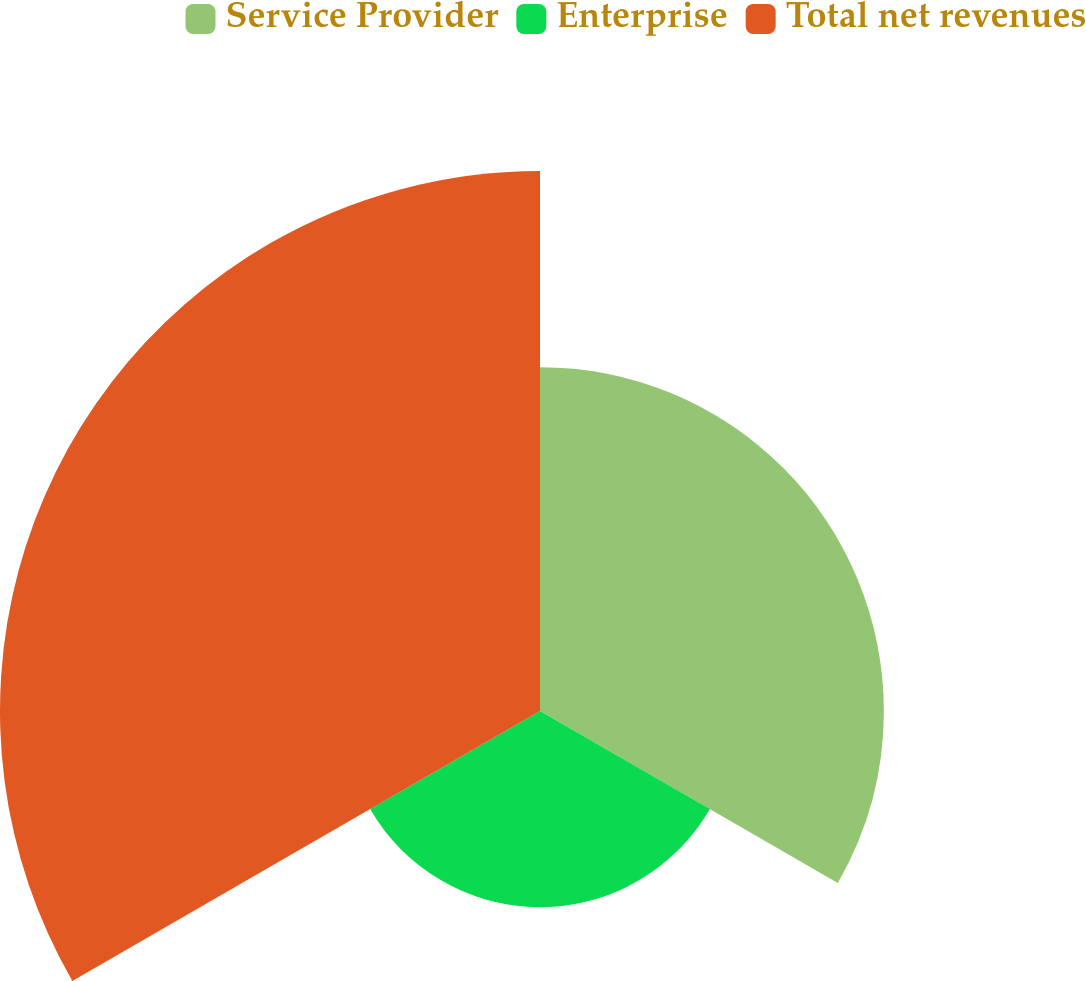Convert chart. <chart><loc_0><loc_0><loc_500><loc_500><pie_chart><fcel>Service Provider<fcel>Enterprise<fcel>Total net revenues<nl><fcel>31.84%<fcel>18.16%<fcel>50.0%<nl></chart> 